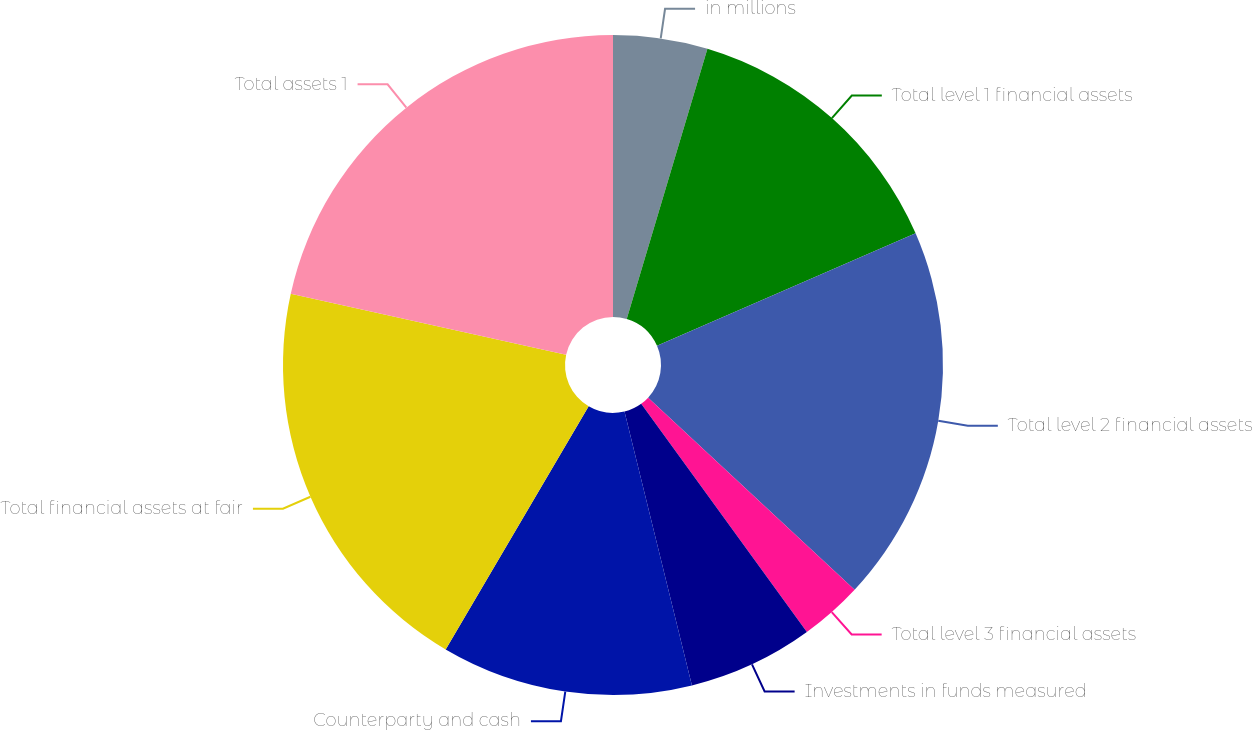<chart> <loc_0><loc_0><loc_500><loc_500><pie_chart><fcel>in millions<fcel>Total level 1 financial assets<fcel>Total level 2 financial assets<fcel>Total level 3 financial assets<fcel>Investments in funds measured<fcel>Counterparty and cash<fcel>Total financial assets at fair<fcel>Total assets 1<nl><fcel>4.62%<fcel>13.85%<fcel>18.46%<fcel>3.08%<fcel>6.15%<fcel>12.31%<fcel>20.0%<fcel>21.54%<nl></chart> 